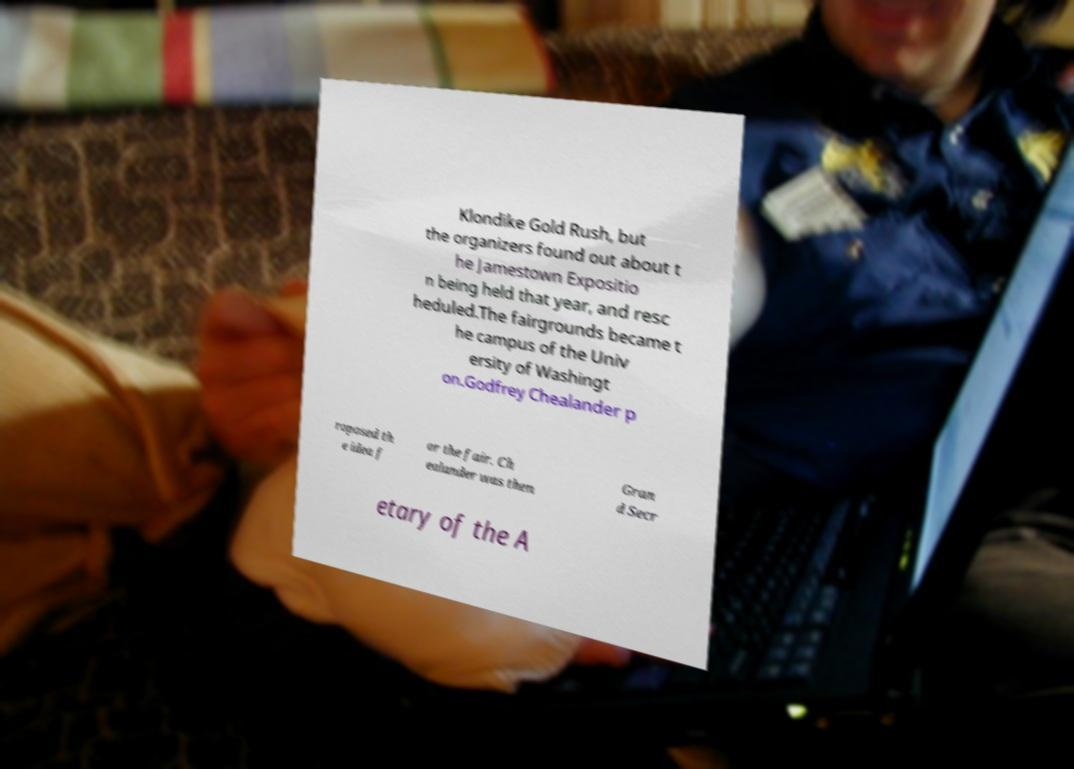Could you extract and type out the text from this image? Klondike Gold Rush, but the organizers found out about t he Jamestown Expositio n being held that year, and resc heduled.The fairgrounds became t he campus of the Univ ersity of Washingt on.Godfrey Chealander p roposed th e idea f or the fair. Ch ealander was then Gran d Secr etary of the A 